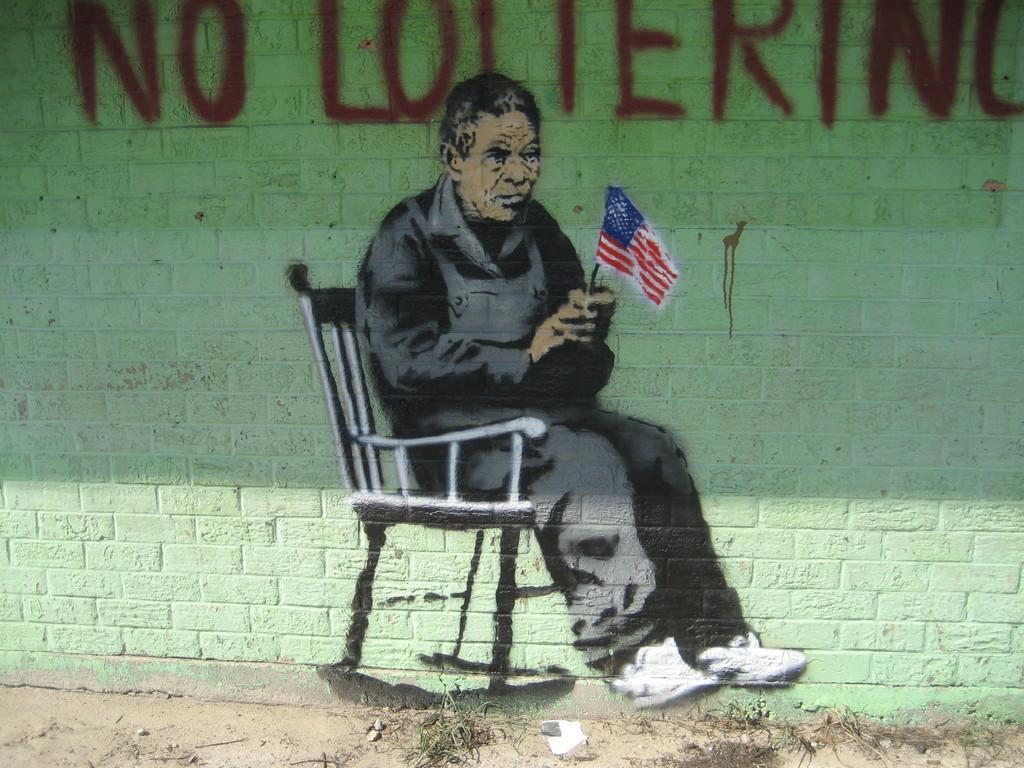How would you summarize this image in a sentence or two? There is a painting of a person sitting on the chair and holding a flag on the wall. We can see text written at the top of this image. 